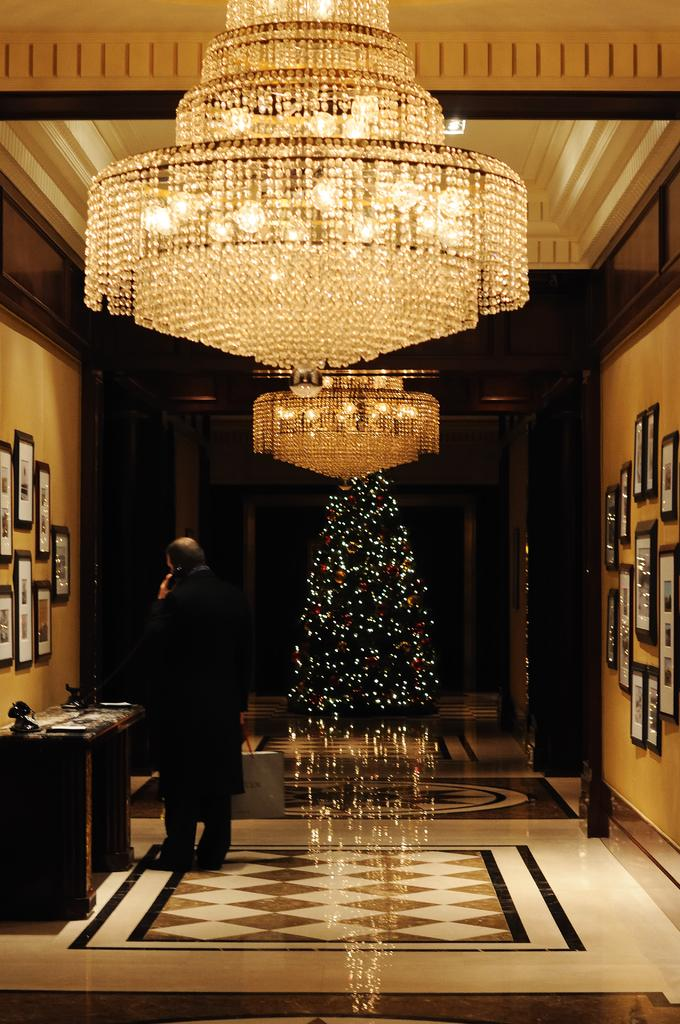What is the main subject of the image? There is a man standing in the image. What is the man holding in the image? The man is holding a telephone handle. What can be seen on the walls in the image? There are frames on the walls in the image. What type of illumination is visible in the image? There are lights visible in the image. How many suns can be seen in the image? There are no suns visible in the image. What is the fifth object in the image? The provided facts do not mention a fifth object, so we cannot answer this question. 